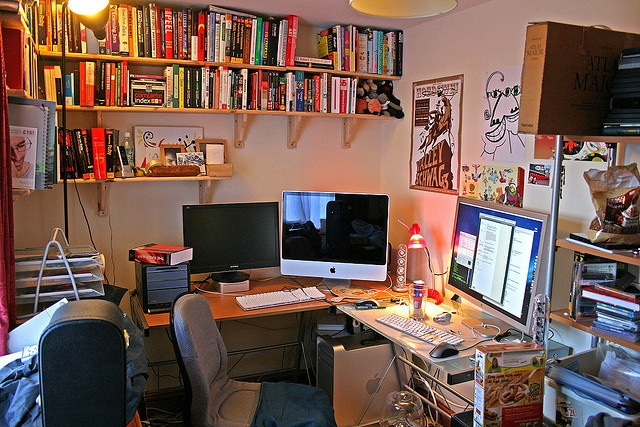Describe the objects in this image and their specific colors. I can see book in black, maroon, and brown tones, tv in black, white, darkgray, and gray tones, chair in black, gray, and maroon tones, tv in black, lavender, and lightblue tones, and tv in black, gray, and purple tones in this image. 